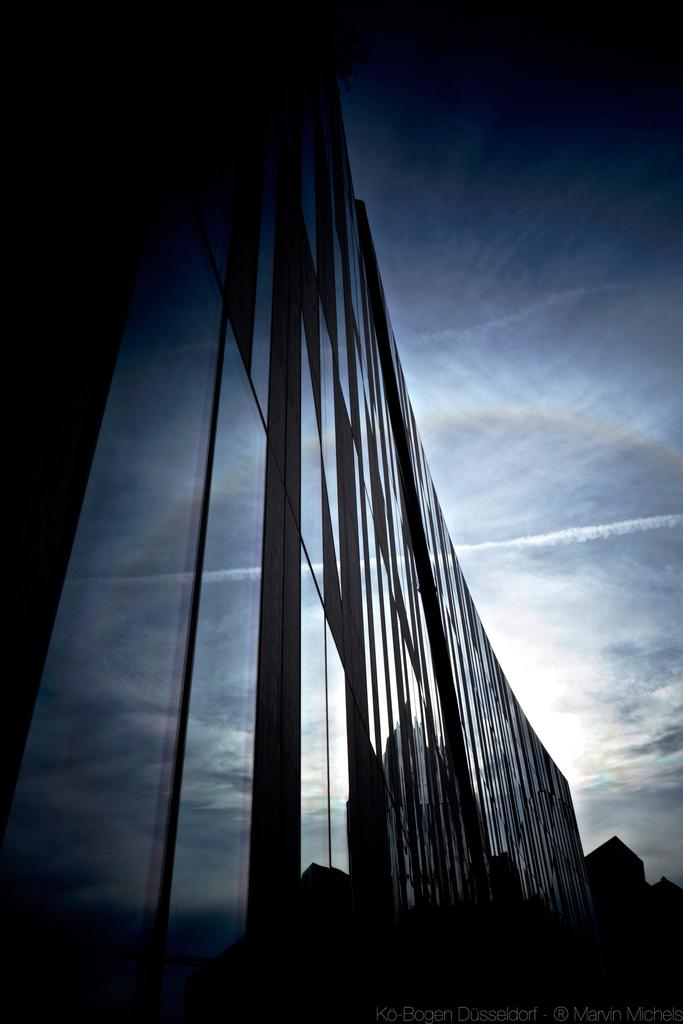What type of structures can be seen in the picture? There are buildings in the picture. How would you describe the sky in the picture? The sky is cloudy in the picture. Is there any text visible in the picture? Yes, there is text at the bottom right corner of the picture. How many beans are hanging from the cobweb in the picture? There is no cobweb or beans present in the picture. What type of pizzas can be seen in the picture? There are no pizzas visible in the image. 